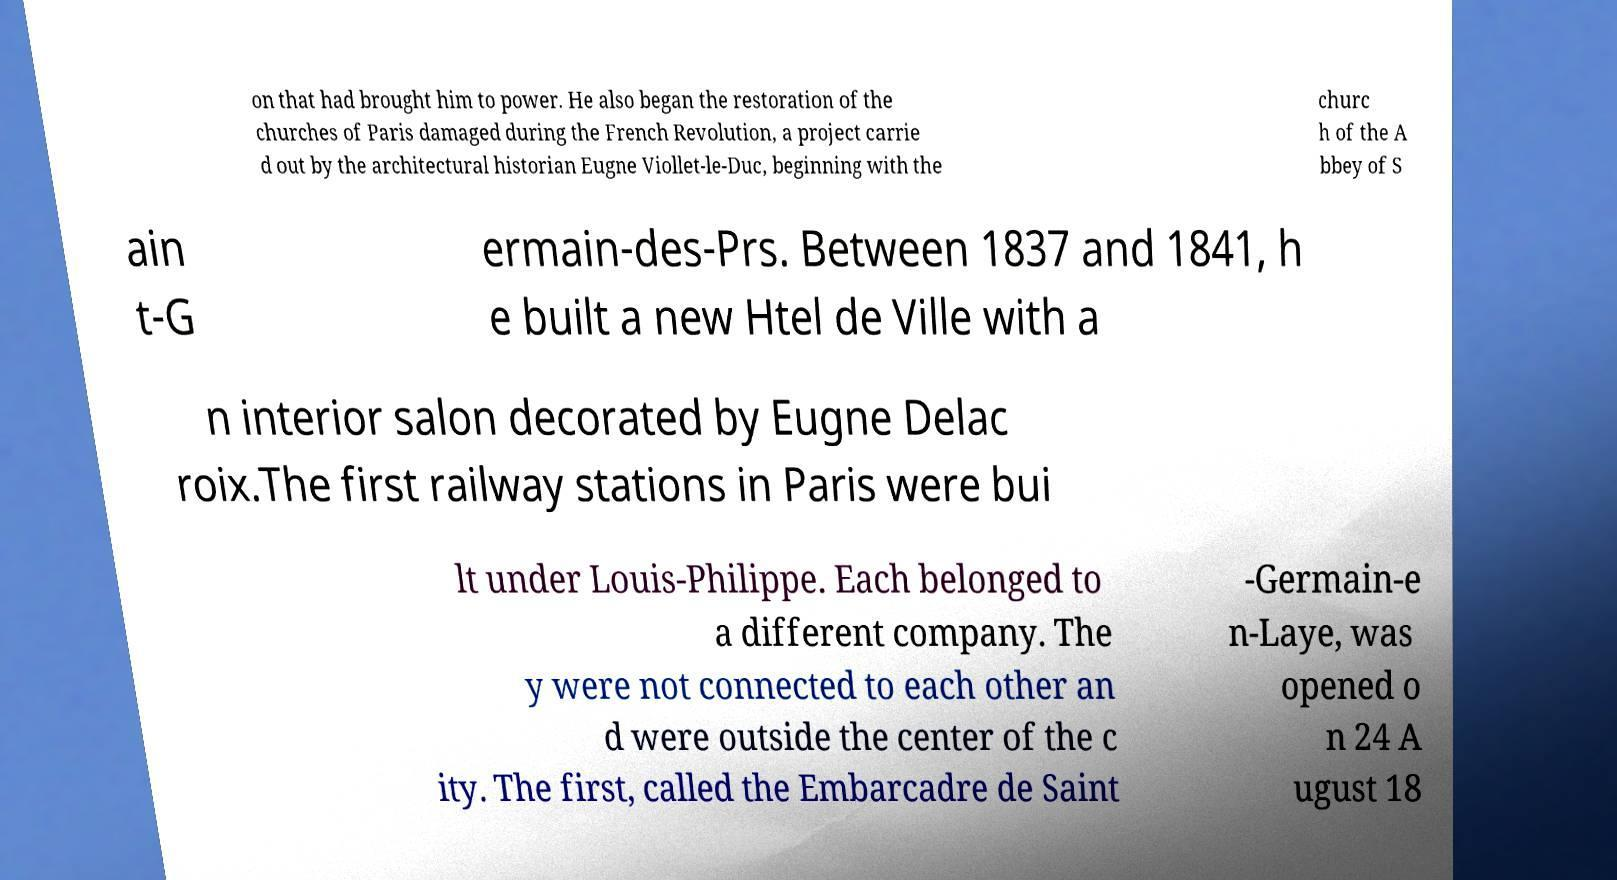Can you read and provide the text displayed in the image?This photo seems to have some interesting text. Can you extract and type it out for me? on that had brought him to power. He also began the restoration of the churches of Paris damaged during the French Revolution, a project carrie d out by the architectural historian Eugne Viollet-le-Duc, beginning with the churc h of the A bbey of S ain t-G ermain-des-Prs. Between 1837 and 1841, h e built a new Htel de Ville with a n interior salon decorated by Eugne Delac roix.The first railway stations in Paris were bui lt under Louis-Philippe. Each belonged to a different company. The y were not connected to each other an d were outside the center of the c ity. The first, called the Embarcadre de Saint -Germain-e n-Laye, was opened o n 24 A ugust 18 